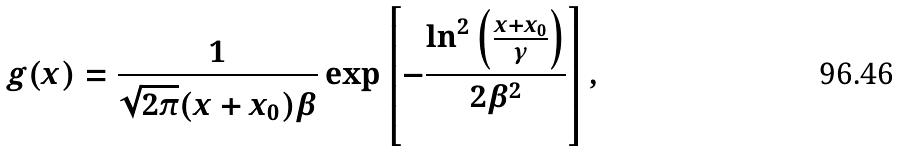Convert formula to latex. <formula><loc_0><loc_0><loc_500><loc_500>g ( x ) = \frac { 1 } { \sqrt { 2 \pi } ( x + x _ { 0 } ) \beta } \exp \left [ { - \frac { \ln ^ { 2 } \left ( \frac { x + x _ { 0 } } { \gamma } \right ) } { 2 \beta ^ { 2 } } } \right ] ,</formula> 